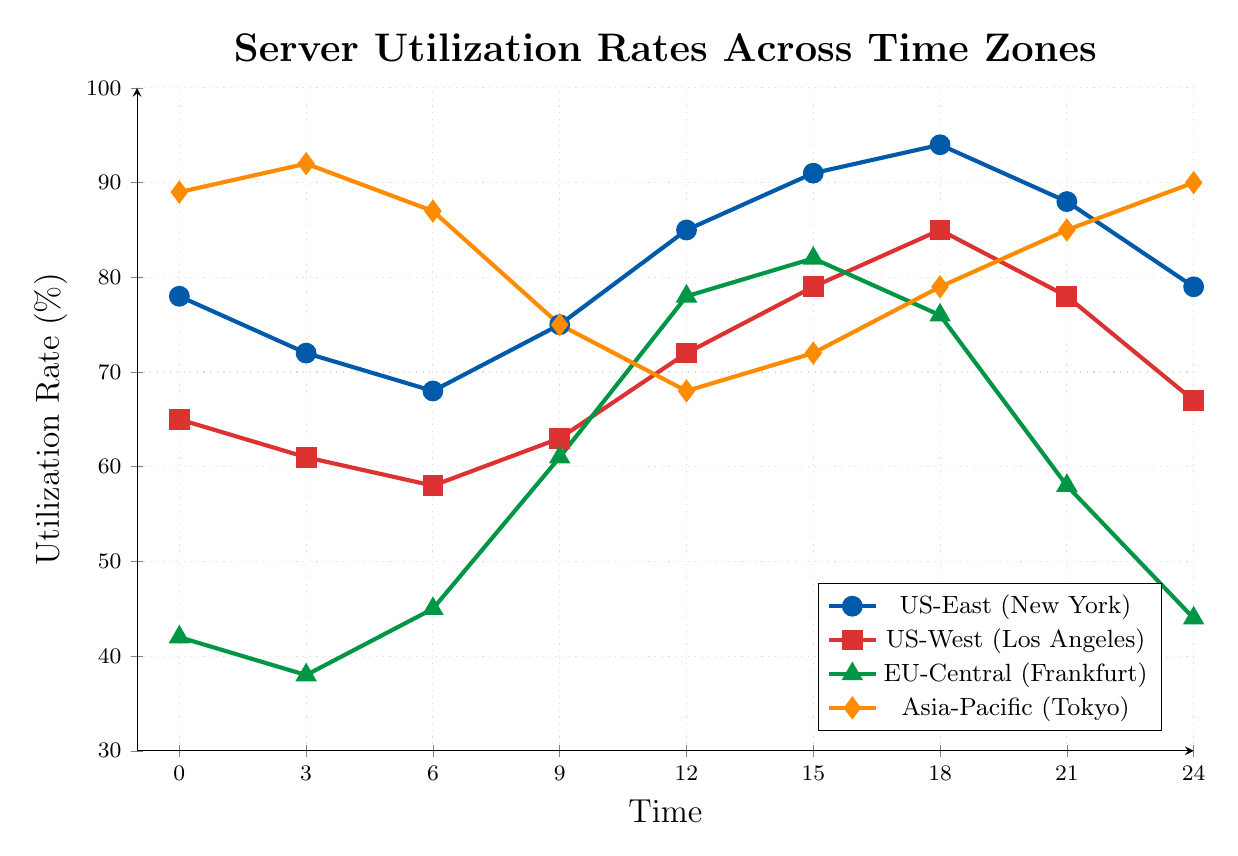What is the highest server utilization rate for the US-East (New York) time zone? To find the highest utilization rate for the US-East (New York) time zone, we look for the maximum value along the blue line in the chart. The maximum value is at 18:00 with a utilization rate of 94%.
Answer: 94% At what time is the server utilization rate equal for the US-West (Los Angeles) and EU-Central (Frankfurt) time zones? To determine where the utilization rate is equal for these time zones, we compare the red and green lines. They intersect at 15:00, where both have a rate of 79%.
Answer: 15:00 Which time zone shows the most significant decrease in utilization rate from 03:00 to 06:00? We observe the drop in utilization rates from 03:00 to 06:00 for each time zone:
- US-East: 72% to 68% (4% drop)
- US-West: 61% to 58% (3% drop)
- EU-Central: 38% to 45% (increase)
- Asia-Pacific: 92% to 87% (5% drop)
The Asia-Pacific time zone has the most significant decrease.
Answer: Asia-Pacific (Tokyo) How many times does the Asia-Pacific (Tokyo) time zone have a higher utilization rate than the EU-Central (Frankfurt) time zone? To answer this, we count the points where the orange line is above the green line:
- 00:00 (89 > 42)
- 03:00 (92 > 38)
- 06:00 (87 > 45)
- 21:00 (85 > 58)
- 24:00 (90 > 44)
This happens 5 times.
Answer: 5 During which time period does the US-West (Los Angeles) time zone's utilization rate first exceed 80%? By examining the red line, we see that the utilization first exceeds 80% at 18:00 with a rate of 85%.
Answer: 18:00 What is the average server utilization rate for the EU-Central (Frankfurt) time zone at 12:00, 15:00, and 18:00? Find the utilization rates at the given times: 78%, 82%, and 76%. Calculate the average:
(78 + 82 + 76) / 3 = 236 / 3 ≈ 78.67%
Answer: 78.67% Which two time zones have the closest utilization rates at 21:00? Compare the values at 21:00 for each time zone:
- US-East: 88%
- US-West: 78%
- EU-Central: 58%
- Asia-Pacific: 85%
US-East and Asia-Pacific have the closest rates (88% and 85%).
Answer: US-East and Asia-Pacific (Tokyo) What is the total increase in the Asia-Pacific (Tokyo) utilization rate from 00:00 to 03:00 and from 21:00 to 24:00? Calculate the increase for each period:
- 00:00 to 03:00: 92 - 89 = 3%
- 21:00 to 24:00: 90 - 85 = 5%
Total increase: 3% + 5% = 8%
Answer: 8% 